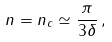Convert formula to latex. <formula><loc_0><loc_0><loc_500><loc_500>n = n _ { c } \simeq \frac { \pi } { 3 \delta } \, ,</formula> 